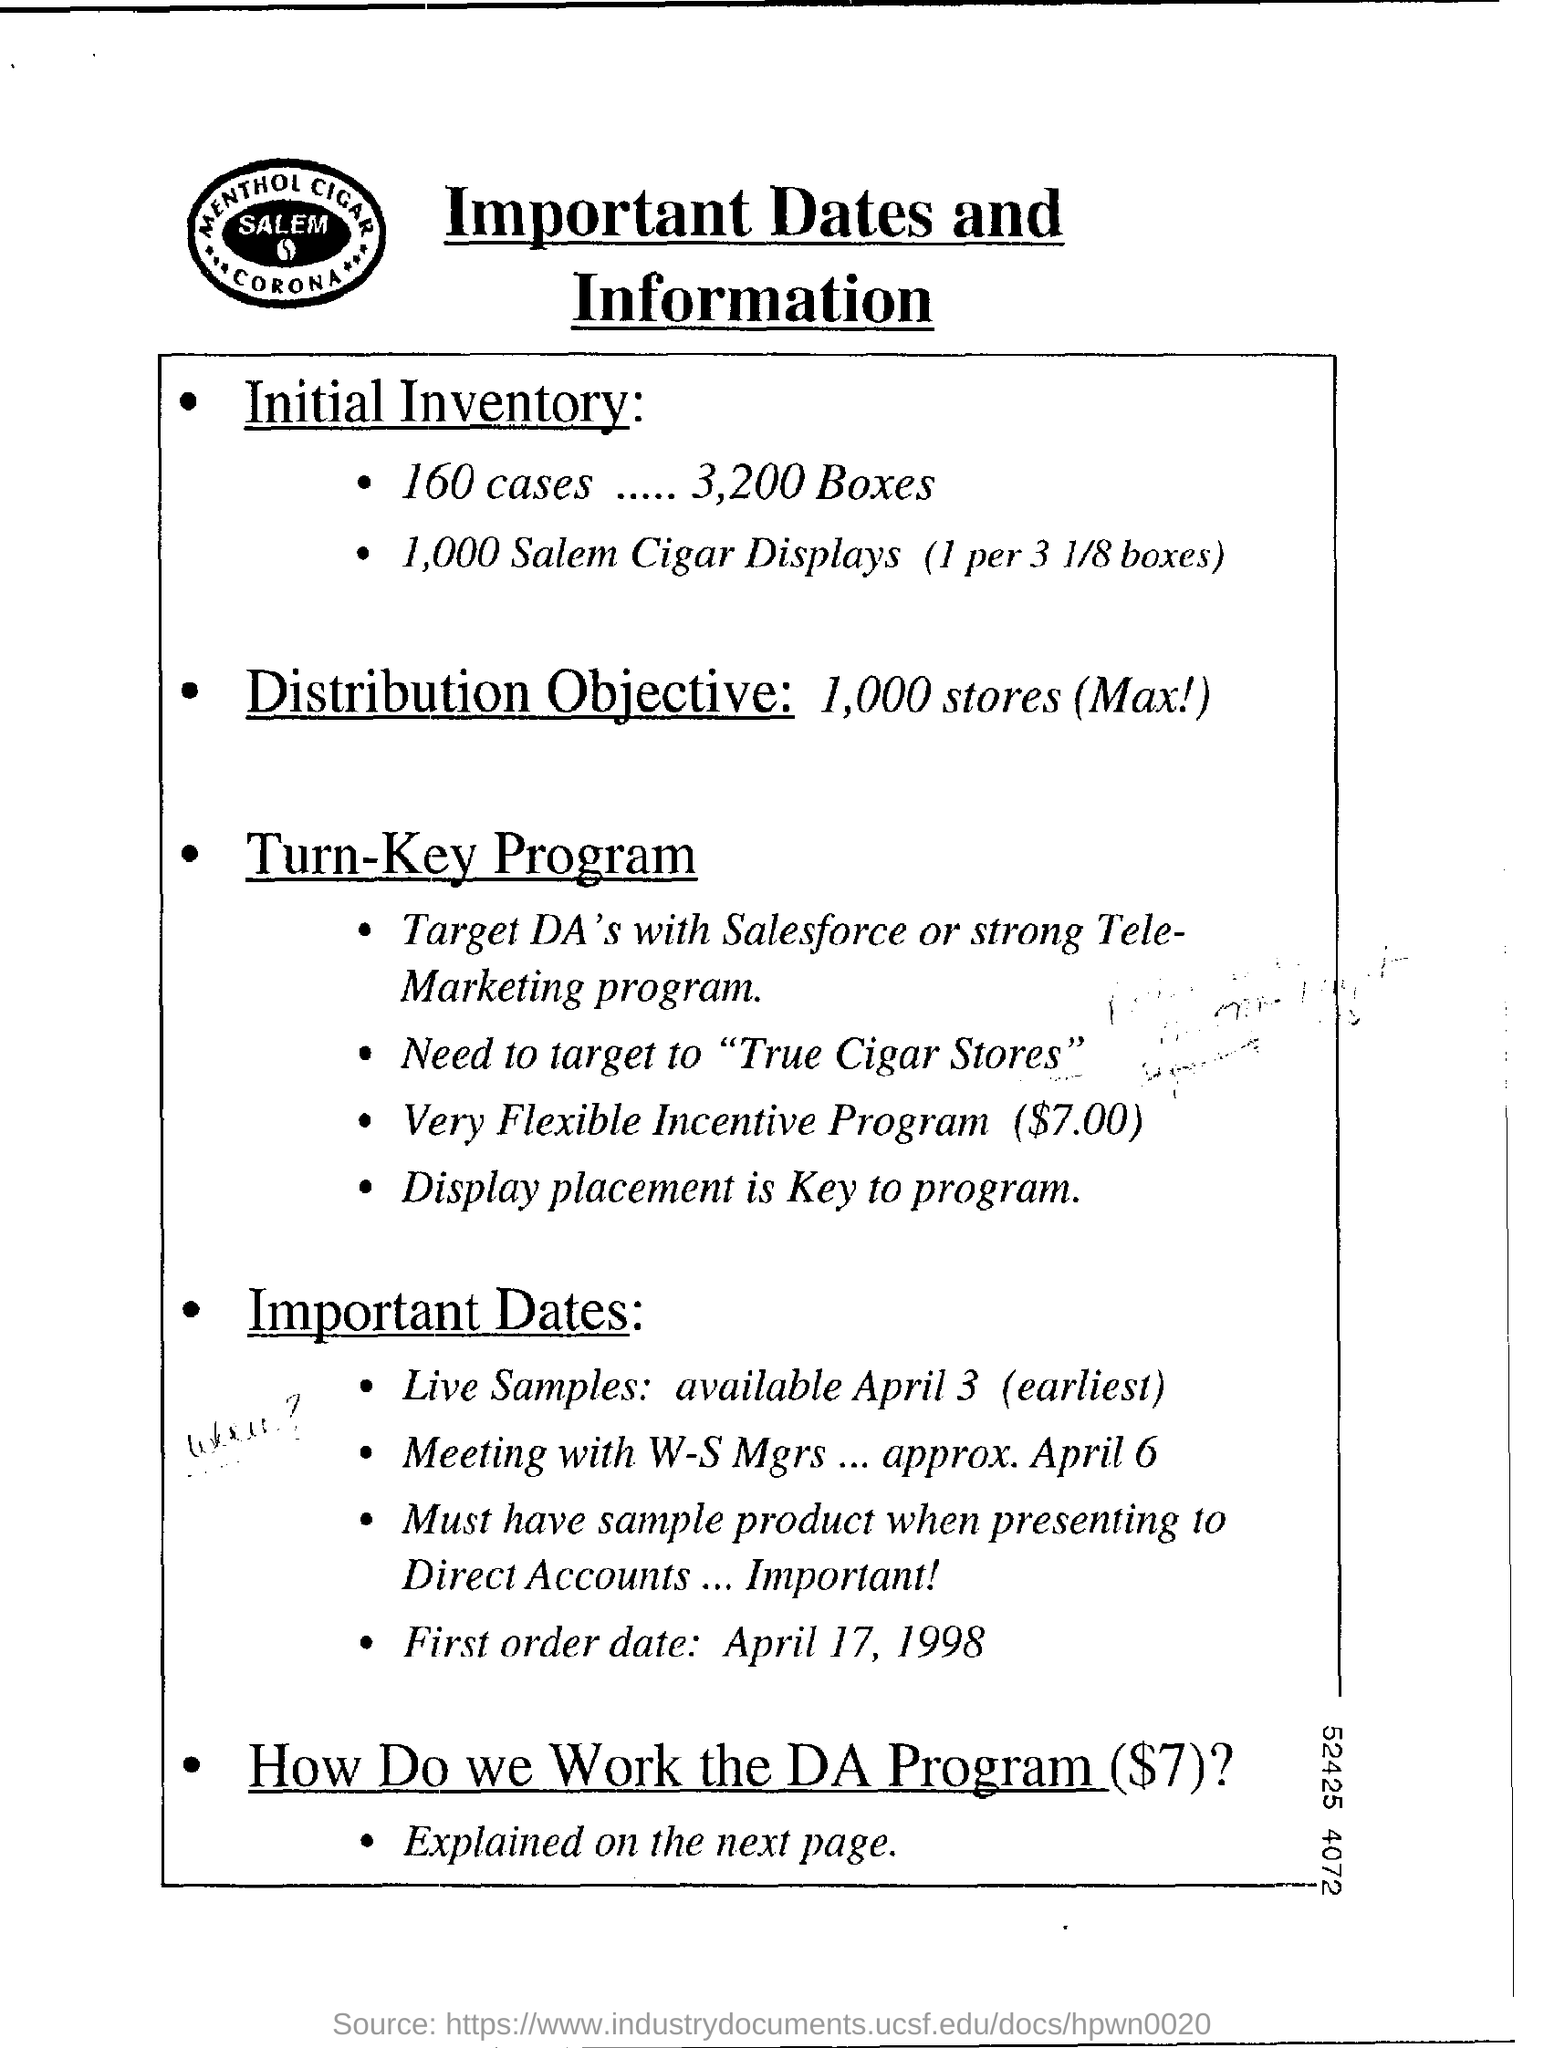What is the heading of the page ?
Your answer should be compact. Important Dates and Information. 